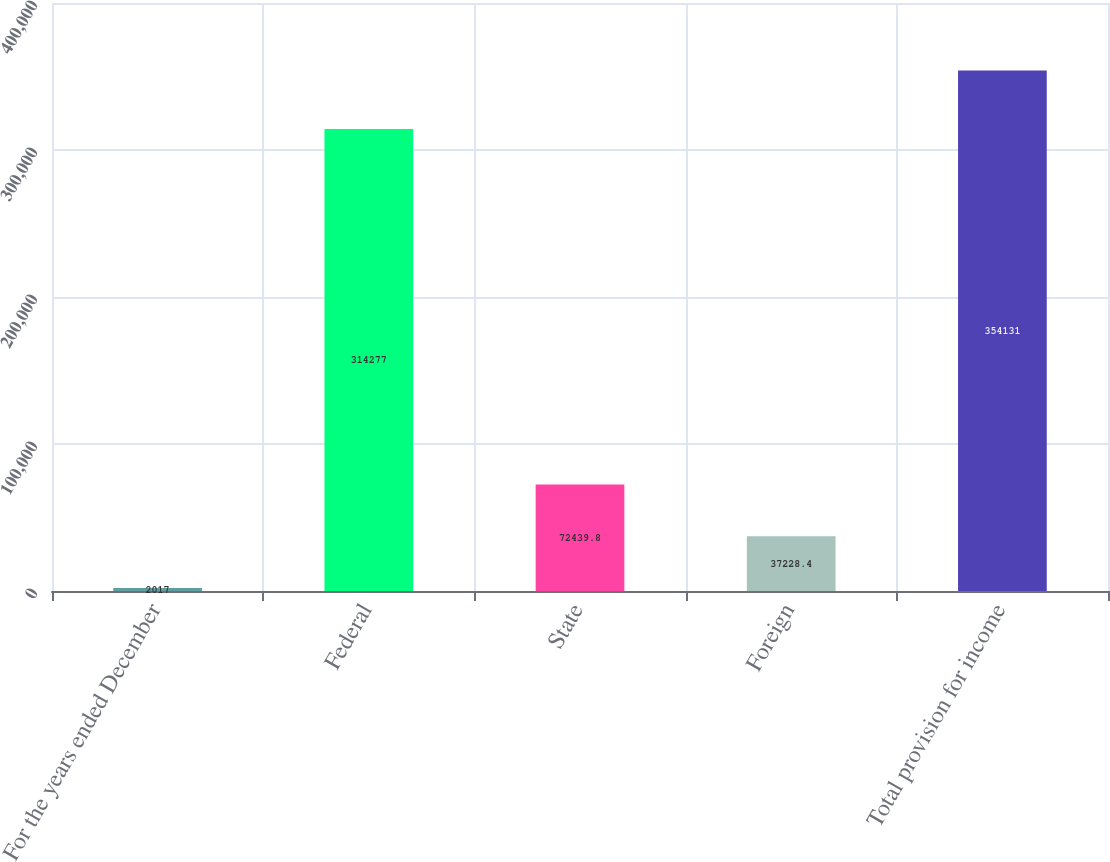<chart> <loc_0><loc_0><loc_500><loc_500><bar_chart><fcel>For the years ended December<fcel>Federal<fcel>State<fcel>Foreign<fcel>Total provision for income<nl><fcel>2017<fcel>314277<fcel>72439.8<fcel>37228.4<fcel>354131<nl></chart> 